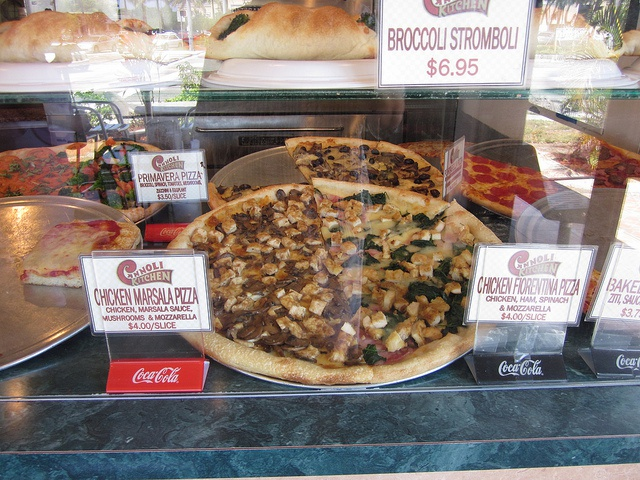Describe the objects in this image and their specific colors. I can see pizza in black, tan, gray, olive, and maroon tones, sandwich in black, tan, and salmon tones, pizza in black, brown, and gray tones, sandwich in black, lightgray, and tan tones, and pizza in black, olive, and maroon tones in this image. 